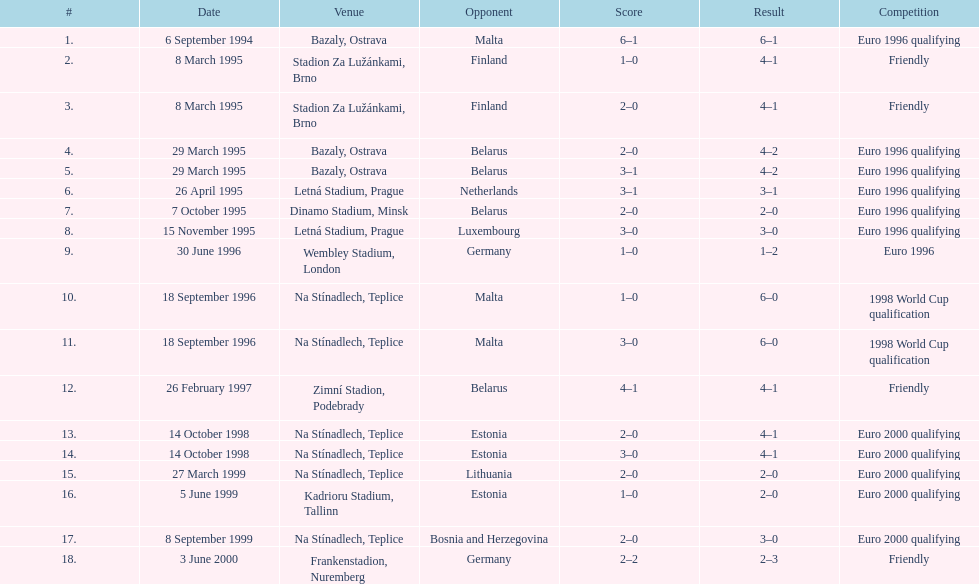List the opponent in which the result was the least out of all the results. Germany. 